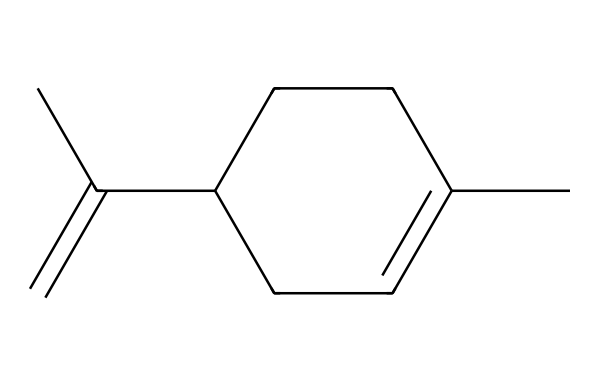What is the molecular formula of limonene? By analyzing the structure, we count the number of carbon (C) and hydrogen (H) atoms. There are 10 carbon atoms and 16 hydrogen atoms in the structure. Therefore, the molecular formula is C10H16.
Answer: C10H16 How many rings are present in the limonene structure? Upon inspecting the chemical structure, we observe one cycloalkane ring formed by the atoms arranged in a closed loop. Therefore, there is one ring present.
Answer: one What type of functional group can be inferred from the structure of limonene? The presence of a double bond (C=C) in the structure indicates that limonene contains an alkene functional group. Alkenes are characterized by at least one carbon-carbon double bond.
Answer: alkene How many double bonds are present in limonene? Looking at the structure, there is one instance of a carbon-carbon double bond in the chain. Therefore, the number of double bonds present is one.
Answer: one Which feature of limonene contributes to its citrus scent? The specific arrangement of the carbon skeleton and the functional group (the double bond) define its properties, particularly its volatility and olfactory appeal. This unique structure is characteristic of terpenes that provide citrus flavors and fragrances.
Answer: terpene 